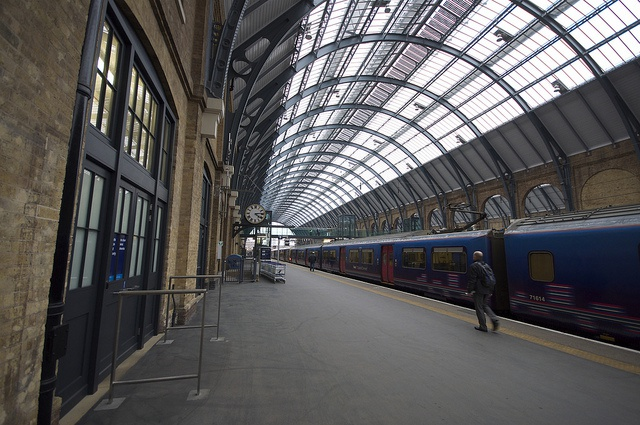Describe the objects in this image and their specific colors. I can see train in black, navy, gray, and darkgray tones, people in black and gray tones, clock in black and gray tones, backpack in black and gray tones, and people in black and gray tones in this image. 